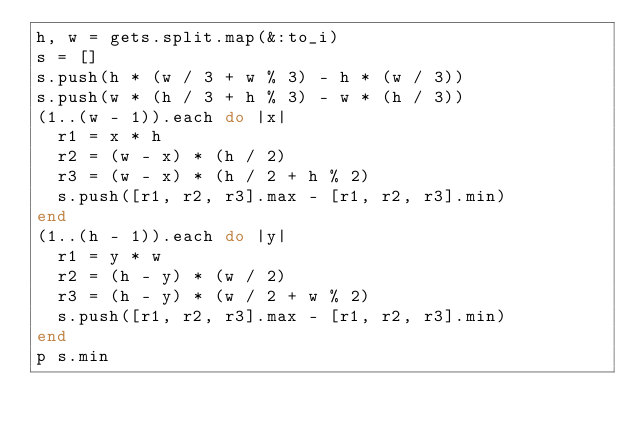<code> <loc_0><loc_0><loc_500><loc_500><_Ruby_>h, w = gets.split.map(&:to_i)
s = []
s.push(h * (w / 3 + w % 3) - h * (w / 3))
s.push(w * (h / 3 + h % 3) - w * (h / 3))
(1..(w - 1)).each do |x|
  r1 = x * h
  r2 = (w - x) * (h / 2)
  r3 = (w - x) * (h / 2 + h % 2)
  s.push([r1, r2, r3].max - [r1, r2, r3].min)
end
(1..(h - 1)).each do |y|
  r1 = y * w
  r2 = (h - y) * (w / 2)
  r3 = (h - y) * (w / 2 + w % 2)
  s.push([r1, r2, r3].max - [r1, r2, r3].min)
end
p s.min</code> 